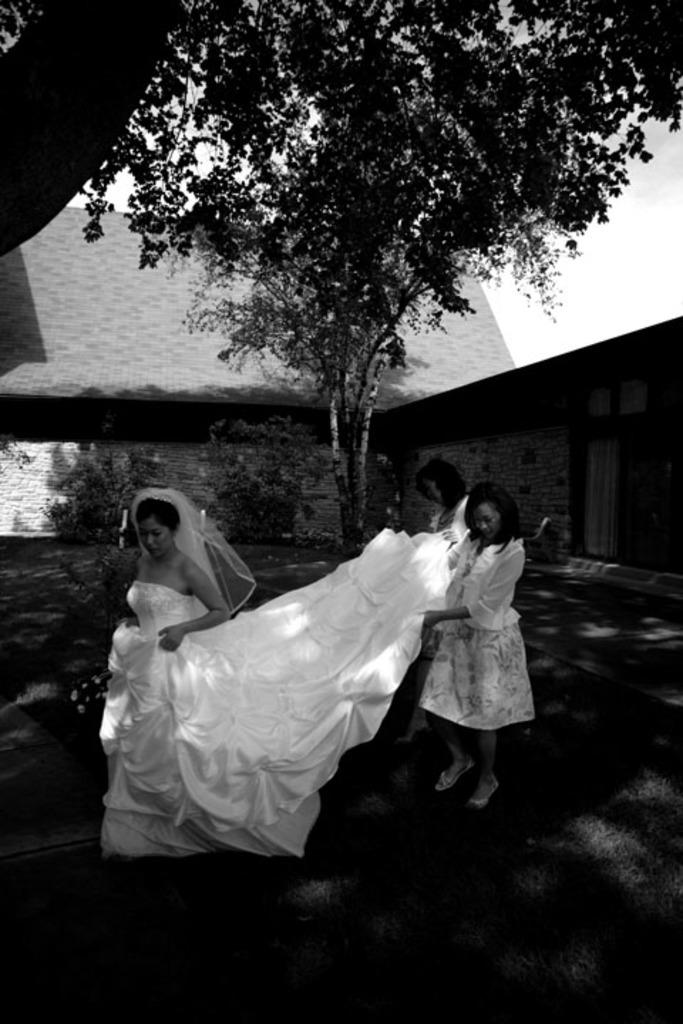What are the main subjects in the center of the image? There are persons standing in the center of the image. What type of natural element can be seen in the image? There is a tree in the image. What can be seen in the background of the image? There are plants and a house in the background of the image. What type of school is visible in the image? There is no school present in the image. What is the limit of the persons standing in the image? The provided facts do not mention any limits or boundaries for the persons standing in the image. 